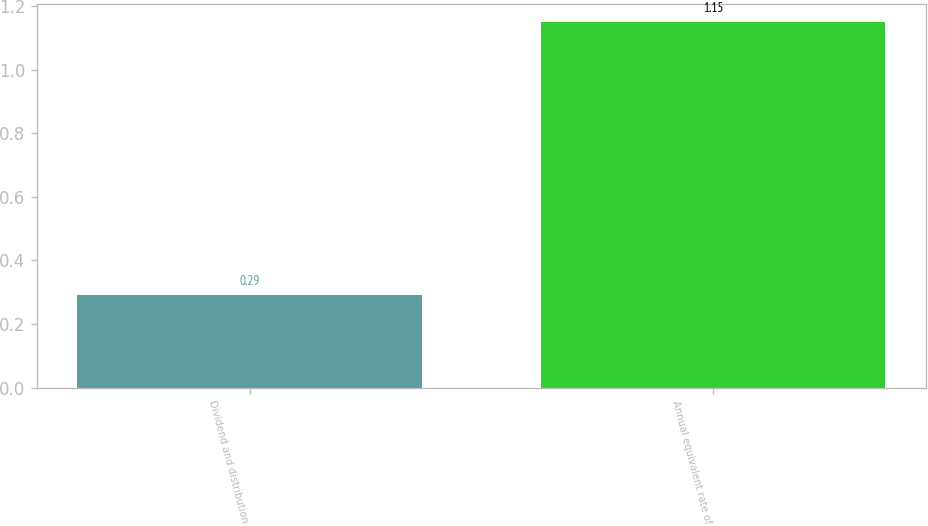Convert chart to OTSL. <chart><loc_0><loc_0><loc_500><loc_500><bar_chart><fcel>Dividend and distribution<fcel>Annual equivalent rate of<nl><fcel>0.29<fcel>1.15<nl></chart> 